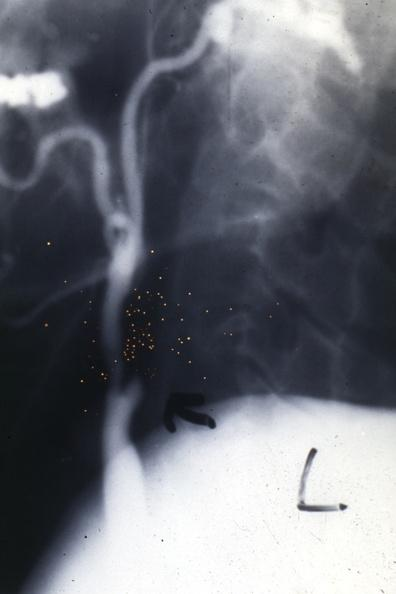s leiomyosarcoma present?
Answer the question using a single word or phrase. No 